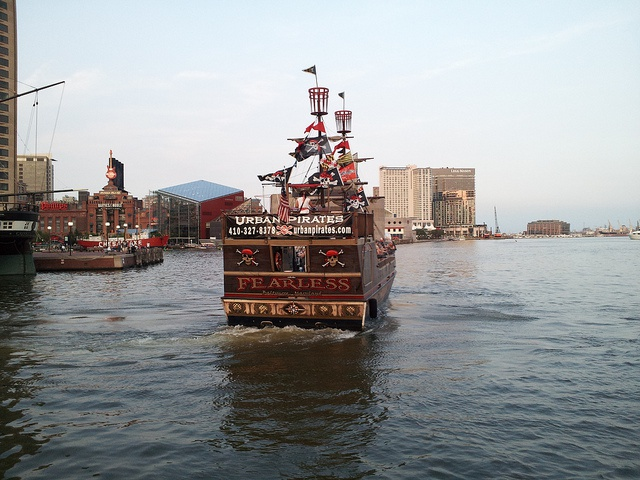Describe the objects in this image and their specific colors. I can see boat in black, maroon, white, and gray tones, boat in black, gray, and darkgray tones, boat in black, brown, maroon, and darkgray tones, boat in black, darkgray, ivory, and lightgray tones, and people in black, lightgray, darkgray, and gray tones in this image. 